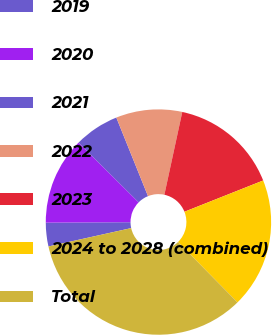Convert chart. <chart><loc_0><loc_0><loc_500><loc_500><pie_chart><fcel>2019<fcel>2020<fcel>2021<fcel>2022<fcel>2023<fcel>2024 to 2028 (combined)<fcel>Total<nl><fcel>3.39%<fcel>12.54%<fcel>6.44%<fcel>9.49%<fcel>15.59%<fcel>18.64%<fcel>33.89%<nl></chart> 